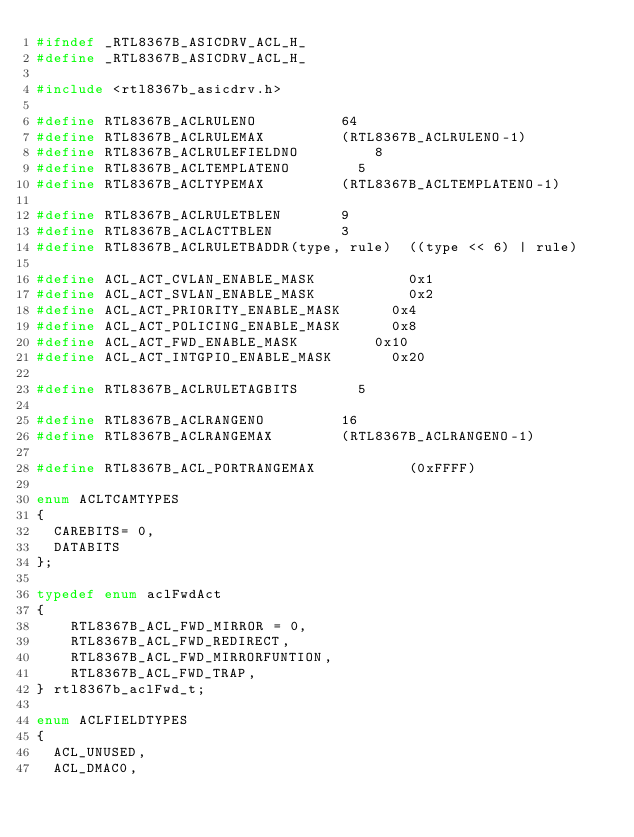Convert code to text. <code><loc_0><loc_0><loc_500><loc_500><_C_>#ifndef _RTL8367B_ASICDRV_ACL_H_
#define _RTL8367B_ASICDRV_ACL_H_

#include <rtl8367b_asicdrv.h>

#define RTL8367B_ACLRULENO					64
#define RTL8367B_ACLRULEMAX					(RTL8367B_ACLRULENO-1)
#define RTL8367B_ACLRULEFIELDNO			    8
#define RTL8367B_ACLTEMPLATENO				5
#define RTL8367B_ACLTYPEMAX					(RTL8367B_ACLTEMPLATENO-1)

#define RTL8367B_ACLRULETBLEN				9
#define RTL8367B_ACLACTTBLEN				3
#define RTL8367B_ACLRULETBADDR(type, rule)	((type << 6) | rule)

#define ACL_ACT_CVLAN_ENABLE_MASK           0x1
#define ACL_ACT_SVLAN_ENABLE_MASK           0x2
#define ACL_ACT_PRIORITY_ENABLE_MASK    	0x4
#define ACL_ACT_POLICING_ENABLE_MASK    	0x8
#define ACL_ACT_FWD_ENABLE_MASK    			0x10
#define ACL_ACT_INTGPIO_ENABLE_MASK    		0x20

#define RTL8367B_ACLRULETAGBITS				5

#define RTL8367B_ACLRANGENO					16
#define RTL8367B_ACLRANGEMAX				(RTL8367B_ACLRANGENO-1)

#define RTL8367B_ACL_PORTRANGEMAX           (0xFFFF)

enum ACLTCAMTYPES
{
	CAREBITS= 0,
	DATABITS
};

typedef enum aclFwdAct
{
    RTL8367B_ACL_FWD_MIRROR = 0,
    RTL8367B_ACL_FWD_REDIRECT,
    RTL8367B_ACL_FWD_MIRRORFUNTION,
    RTL8367B_ACL_FWD_TRAP,
} rtl8367b_aclFwd_t;

enum ACLFIELDTYPES
{
	ACL_UNUSED,
	ACL_DMAC0,</code> 